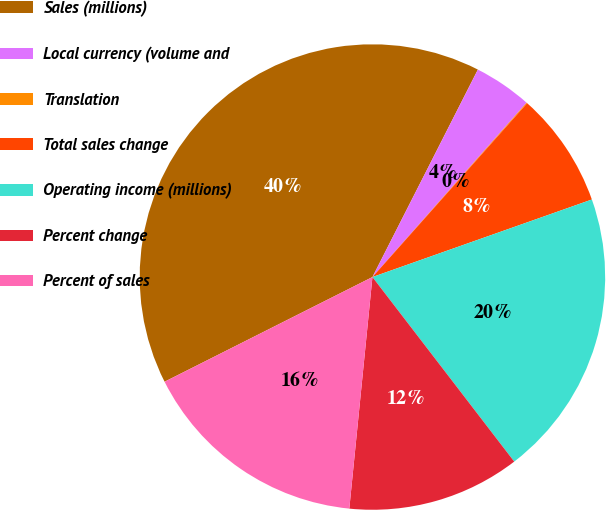<chart> <loc_0><loc_0><loc_500><loc_500><pie_chart><fcel>Sales (millions)<fcel>Local currency (volume and<fcel>Translation<fcel>Total sales change<fcel>Operating income (millions)<fcel>Percent change<fcel>Percent of sales<nl><fcel>39.91%<fcel>4.04%<fcel>0.05%<fcel>8.02%<fcel>19.98%<fcel>12.01%<fcel>15.99%<nl></chart> 